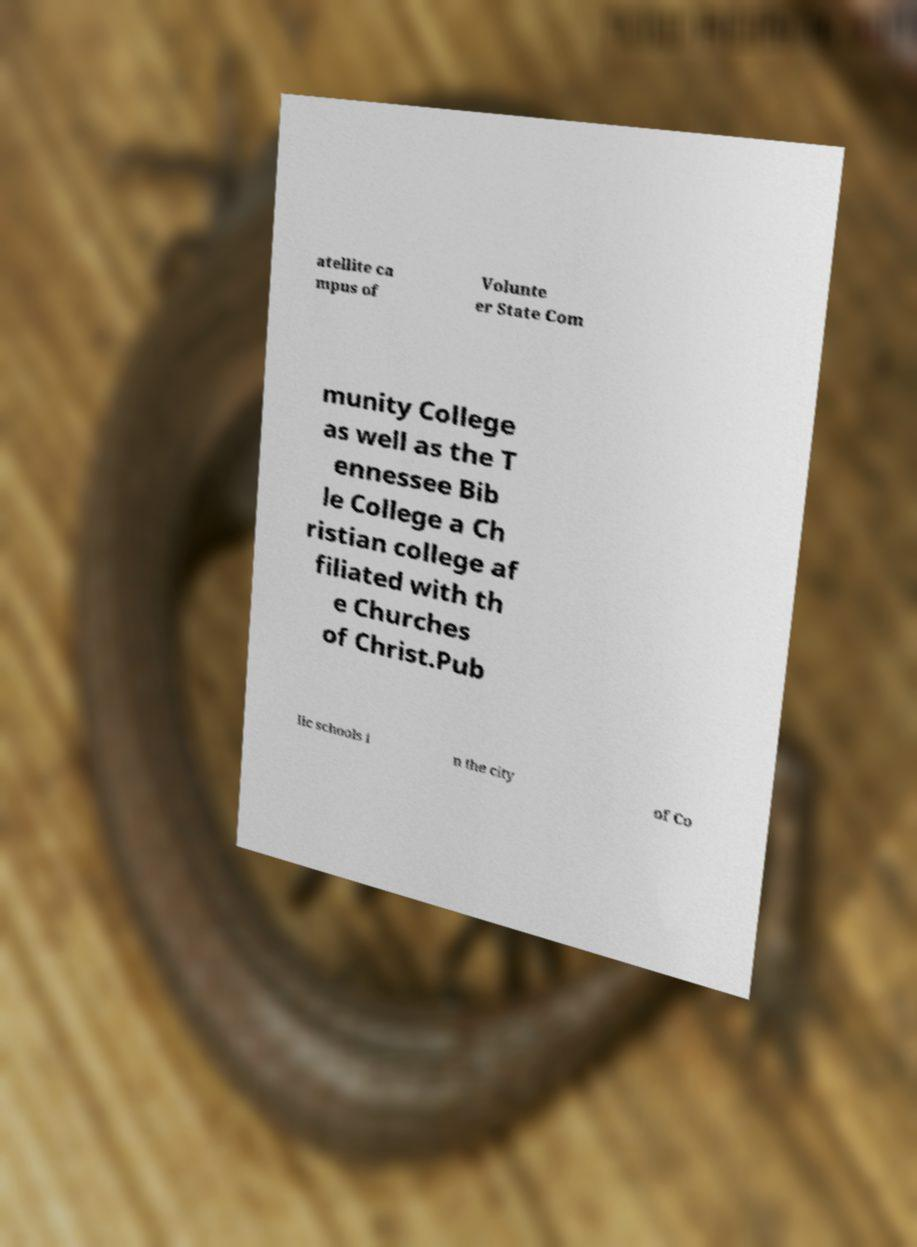Can you read and provide the text displayed in the image?This photo seems to have some interesting text. Can you extract and type it out for me? atellite ca mpus of Volunte er State Com munity College as well as the T ennessee Bib le College a Ch ristian college af filiated with th e Churches of Christ.Pub lic schools i n the city of Co 